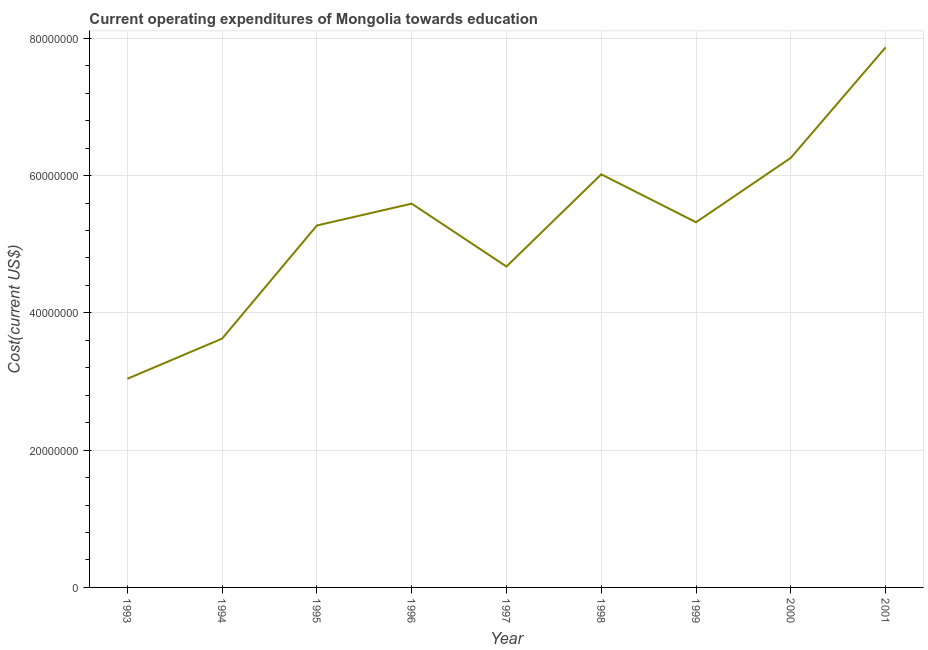What is the education expenditure in 1996?
Your response must be concise. 5.59e+07. Across all years, what is the maximum education expenditure?
Offer a terse response. 7.87e+07. Across all years, what is the minimum education expenditure?
Offer a terse response. 3.04e+07. In which year was the education expenditure maximum?
Make the answer very short. 2001. In which year was the education expenditure minimum?
Keep it short and to the point. 1993. What is the sum of the education expenditure?
Provide a succinct answer. 4.77e+08. What is the difference between the education expenditure in 1998 and 2001?
Your answer should be compact. -1.85e+07. What is the average education expenditure per year?
Your answer should be very brief. 5.30e+07. What is the median education expenditure?
Keep it short and to the point. 5.32e+07. In how many years, is the education expenditure greater than 12000000 US$?
Provide a short and direct response. 9. What is the ratio of the education expenditure in 1996 to that in 1999?
Make the answer very short. 1.05. Is the education expenditure in 1994 less than that in 2001?
Offer a very short reply. Yes. What is the difference between the highest and the second highest education expenditure?
Make the answer very short. 1.61e+07. What is the difference between the highest and the lowest education expenditure?
Keep it short and to the point. 4.83e+07. What is the difference between two consecutive major ticks on the Y-axis?
Offer a very short reply. 2.00e+07. Are the values on the major ticks of Y-axis written in scientific E-notation?
Offer a very short reply. No. Does the graph contain any zero values?
Offer a very short reply. No. What is the title of the graph?
Offer a very short reply. Current operating expenditures of Mongolia towards education. What is the label or title of the Y-axis?
Provide a short and direct response. Cost(current US$). What is the Cost(current US$) in 1993?
Your response must be concise. 3.04e+07. What is the Cost(current US$) of 1994?
Provide a succinct answer. 3.63e+07. What is the Cost(current US$) in 1995?
Your answer should be very brief. 5.27e+07. What is the Cost(current US$) in 1996?
Provide a short and direct response. 5.59e+07. What is the Cost(current US$) in 1997?
Provide a succinct answer. 4.68e+07. What is the Cost(current US$) of 1998?
Your answer should be very brief. 6.02e+07. What is the Cost(current US$) in 1999?
Offer a terse response. 5.32e+07. What is the Cost(current US$) in 2000?
Your response must be concise. 6.26e+07. What is the Cost(current US$) in 2001?
Provide a short and direct response. 7.87e+07. What is the difference between the Cost(current US$) in 1993 and 1994?
Make the answer very short. -5.86e+06. What is the difference between the Cost(current US$) in 1993 and 1995?
Your answer should be compact. -2.23e+07. What is the difference between the Cost(current US$) in 1993 and 1996?
Your answer should be very brief. -2.55e+07. What is the difference between the Cost(current US$) in 1993 and 1997?
Provide a short and direct response. -1.64e+07. What is the difference between the Cost(current US$) in 1993 and 1998?
Offer a terse response. -2.98e+07. What is the difference between the Cost(current US$) in 1993 and 1999?
Offer a very short reply. -2.28e+07. What is the difference between the Cost(current US$) in 1993 and 2000?
Your answer should be compact. -3.22e+07. What is the difference between the Cost(current US$) in 1993 and 2001?
Provide a short and direct response. -4.83e+07. What is the difference between the Cost(current US$) in 1994 and 1995?
Ensure brevity in your answer.  -1.65e+07. What is the difference between the Cost(current US$) in 1994 and 1996?
Offer a very short reply. -1.97e+07. What is the difference between the Cost(current US$) in 1994 and 1997?
Your answer should be very brief. -1.05e+07. What is the difference between the Cost(current US$) in 1994 and 1998?
Offer a very short reply. -2.39e+07. What is the difference between the Cost(current US$) in 1994 and 1999?
Offer a terse response. -1.70e+07. What is the difference between the Cost(current US$) in 1994 and 2000?
Offer a very short reply. -2.63e+07. What is the difference between the Cost(current US$) in 1994 and 2001?
Your response must be concise. -4.24e+07. What is the difference between the Cost(current US$) in 1995 and 1996?
Offer a very short reply. -3.18e+06. What is the difference between the Cost(current US$) in 1995 and 1997?
Give a very brief answer. 5.98e+06. What is the difference between the Cost(current US$) in 1995 and 1998?
Provide a short and direct response. -7.45e+06. What is the difference between the Cost(current US$) in 1995 and 1999?
Provide a succinct answer. -4.72e+05. What is the difference between the Cost(current US$) in 1995 and 2000?
Keep it short and to the point. -9.85e+06. What is the difference between the Cost(current US$) in 1995 and 2001?
Offer a very short reply. -2.59e+07. What is the difference between the Cost(current US$) in 1996 and 1997?
Your answer should be compact. 9.16e+06. What is the difference between the Cost(current US$) in 1996 and 1998?
Provide a short and direct response. -4.27e+06. What is the difference between the Cost(current US$) in 1996 and 1999?
Offer a very short reply. 2.71e+06. What is the difference between the Cost(current US$) in 1996 and 2000?
Provide a short and direct response. -6.67e+06. What is the difference between the Cost(current US$) in 1996 and 2001?
Provide a succinct answer. -2.28e+07. What is the difference between the Cost(current US$) in 1997 and 1998?
Your answer should be very brief. -1.34e+07. What is the difference between the Cost(current US$) in 1997 and 1999?
Your answer should be compact. -6.45e+06. What is the difference between the Cost(current US$) in 1997 and 2000?
Provide a short and direct response. -1.58e+07. What is the difference between the Cost(current US$) in 1997 and 2001?
Make the answer very short. -3.19e+07. What is the difference between the Cost(current US$) in 1998 and 1999?
Give a very brief answer. 6.98e+06. What is the difference between the Cost(current US$) in 1998 and 2000?
Your answer should be very brief. -2.40e+06. What is the difference between the Cost(current US$) in 1998 and 2001?
Make the answer very short. -1.85e+07. What is the difference between the Cost(current US$) in 1999 and 2000?
Your response must be concise. -9.38e+06. What is the difference between the Cost(current US$) in 1999 and 2001?
Give a very brief answer. -2.55e+07. What is the difference between the Cost(current US$) in 2000 and 2001?
Your answer should be very brief. -1.61e+07. What is the ratio of the Cost(current US$) in 1993 to that in 1994?
Provide a succinct answer. 0.84. What is the ratio of the Cost(current US$) in 1993 to that in 1995?
Provide a short and direct response. 0.58. What is the ratio of the Cost(current US$) in 1993 to that in 1996?
Your response must be concise. 0.54. What is the ratio of the Cost(current US$) in 1993 to that in 1997?
Offer a very short reply. 0.65. What is the ratio of the Cost(current US$) in 1993 to that in 1998?
Offer a terse response. 0.51. What is the ratio of the Cost(current US$) in 1993 to that in 1999?
Your response must be concise. 0.57. What is the ratio of the Cost(current US$) in 1993 to that in 2000?
Provide a succinct answer. 0.49. What is the ratio of the Cost(current US$) in 1993 to that in 2001?
Offer a terse response. 0.39. What is the ratio of the Cost(current US$) in 1994 to that in 1995?
Your response must be concise. 0.69. What is the ratio of the Cost(current US$) in 1994 to that in 1996?
Give a very brief answer. 0.65. What is the ratio of the Cost(current US$) in 1994 to that in 1997?
Offer a very short reply. 0.78. What is the ratio of the Cost(current US$) in 1994 to that in 1998?
Your answer should be compact. 0.6. What is the ratio of the Cost(current US$) in 1994 to that in 1999?
Your answer should be compact. 0.68. What is the ratio of the Cost(current US$) in 1994 to that in 2000?
Make the answer very short. 0.58. What is the ratio of the Cost(current US$) in 1994 to that in 2001?
Give a very brief answer. 0.46. What is the ratio of the Cost(current US$) in 1995 to that in 1996?
Your response must be concise. 0.94. What is the ratio of the Cost(current US$) in 1995 to that in 1997?
Offer a very short reply. 1.13. What is the ratio of the Cost(current US$) in 1995 to that in 1998?
Your answer should be very brief. 0.88. What is the ratio of the Cost(current US$) in 1995 to that in 2000?
Your answer should be very brief. 0.84. What is the ratio of the Cost(current US$) in 1995 to that in 2001?
Your response must be concise. 0.67. What is the ratio of the Cost(current US$) in 1996 to that in 1997?
Provide a succinct answer. 1.2. What is the ratio of the Cost(current US$) in 1996 to that in 1998?
Your answer should be very brief. 0.93. What is the ratio of the Cost(current US$) in 1996 to that in 1999?
Ensure brevity in your answer.  1.05. What is the ratio of the Cost(current US$) in 1996 to that in 2000?
Ensure brevity in your answer.  0.89. What is the ratio of the Cost(current US$) in 1996 to that in 2001?
Ensure brevity in your answer.  0.71. What is the ratio of the Cost(current US$) in 1997 to that in 1998?
Provide a short and direct response. 0.78. What is the ratio of the Cost(current US$) in 1997 to that in 1999?
Your response must be concise. 0.88. What is the ratio of the Cost(current US$) in 1997 to that in 2000?
Ensure brevity in your answer.  0.75. What is the ratio of the Cost(current US$) in 1997 to that in 2001?
Provide a short and direct response. 0.59. What is the ratio of the Cost(current US$) in 1998 to that in 1999?
Provide a short and direct response. 1.13. What is the ratio of the Cost(current US$) in 1998 to that in 2001?
Your answer should be compact. 0.77. What is the ratio of the Cost(current US$) in 1999 to that in 2000?
Provide a succinct answer. 0.85. What is the ratio of the Cost(current US$) in 1999 to that in 2001?
Your answer should be compact. 0.68. What is the ratio of the Cost(current US$) in 2000 to that in 2001?
Your answer should be very brief. 0.8. 